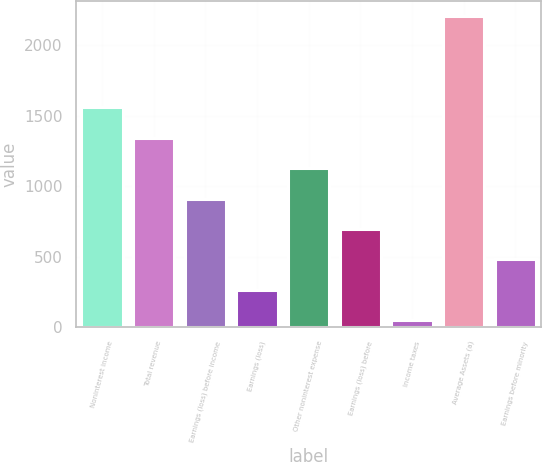Convert chart. <chart><loc_0><loc_0><loc_500><loc_500><bar_chart><fcel>Noninterest income<fcel>Total revenue<fcel>Earnings (loss) before income<fcel>Earnings (loss)<fcel>Other noninterest expense<fcel>Earnings (loss) before<fcel>Income taxes<fcel>Average Assets (a)<fcel>Earnings before minority<nl><fcel>1558.4<fcel>1343.2<fcel>912.8<fcel>267.2<fcel>1128<fcel>697.6<fcel>52<fcel>2204<fcel>482.4<nl></chart> 